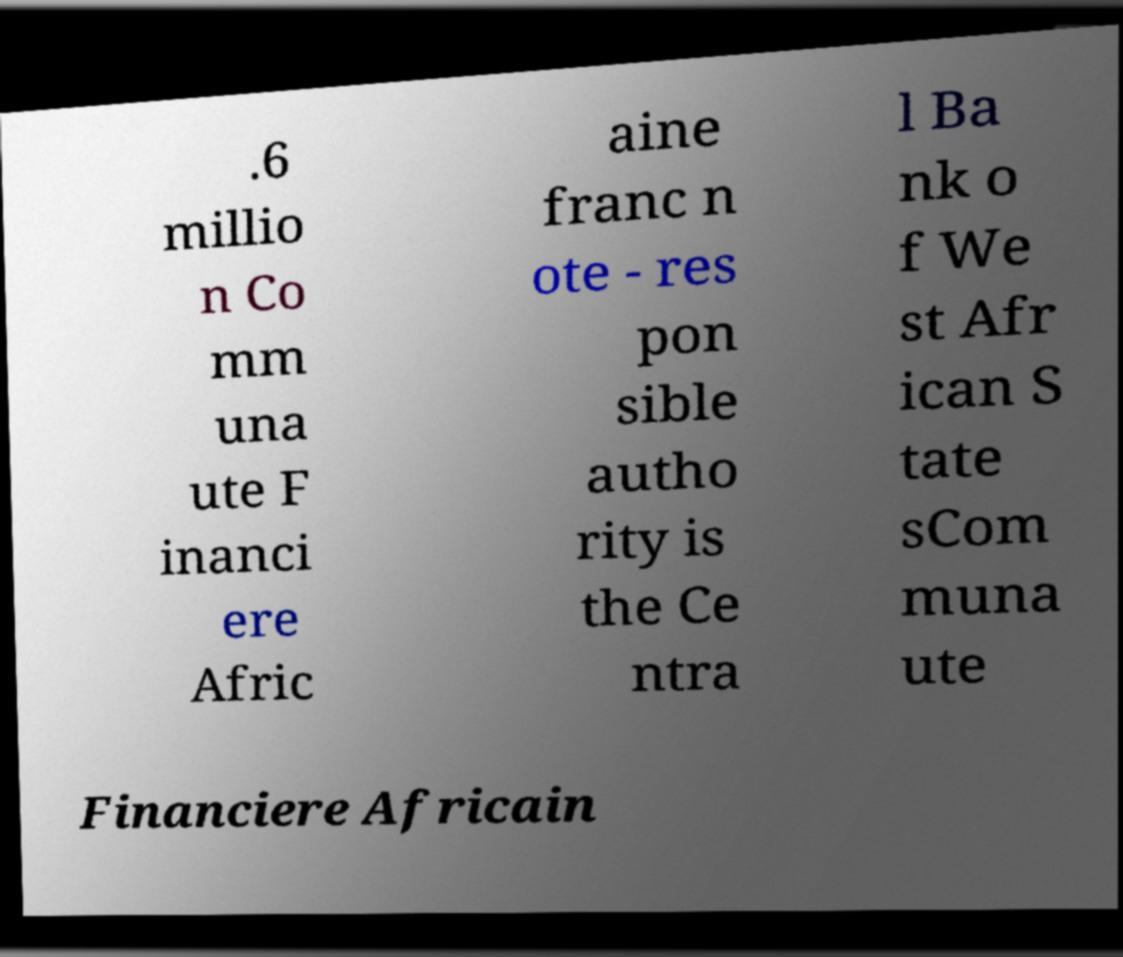For documentation purposes, I need the text within this image transcribed. Could you provide that? .6 millio n Co mm una ute F inanci ere Afric aine franc n ote - res pon sible autho rity is the Ce ntra l Ba nk o f We st Afr ican S tate sCom muna ute Financiere Africain 